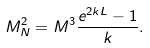Convert formula to latex. <formula><loc_0><loc_0><loc_500><loc_500>M ^ { 2 } _ { N } = M ^ { 3 } \frac { e ^ { 2 k L } - 1 } { k } .</formula> 